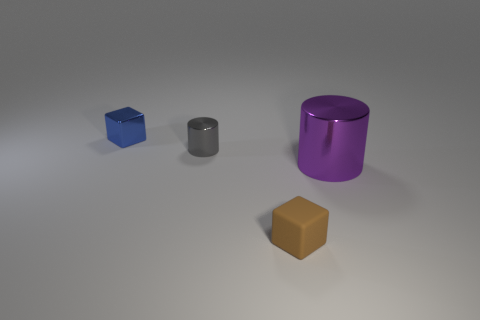What is the shape of the metallic object right of the small block that is in front of the big purple cylinder?
Provide a short and direct response. Cylinder. What is the shape of the large shiny object?
Keep it short and to the point. Cylinder. What material is the small cube on the right side of the cylinder that is to the left of the tiny block that is in front of the tiny blue cube?
Provide a succinct answer. Rubber. What number of other things are there of the same material as the tiny brown cube
Your answer should be very brief. 0. There is a cylinder that is behind the purple object; what number of big shiny things are on the left side of it?
Make the answer very short. 0. How many balls are brown objects or gray shiny objects?
Give a very brief answer. 0. There is a metal object that is both on the left side of the purple object and in front of the metal block; what is its color?
Provide a short and direct response. Gray. Is there any other thing that is the same color as the small shiny block?
Keep it short and to the point. No. What is the color of the small cube that is in front of the large purple metal cylinder in front of the tiny cylinder?
Make the answer very short. Brown. Is the brown rubber block the same size as the purple metal cylinder?
Offer a very short reply. No. 